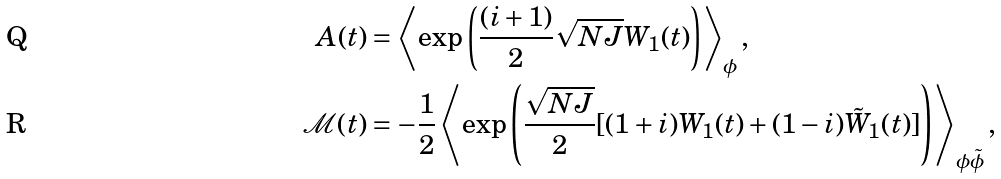Convert formula to latex. <formula><loc_0><loc_0><loc_500><loc_500>A ( t ) & = \left \langle \exp \left ( \frac { ( i + 1 ) } { 2 } \sqrt { N J } W _ { 1 } ( t ) \right ) \right \rangle _ { \phi } , \\ \mathcal { M } ( t ) & = - \frac { 1 } { 2 } \left \langle \exp \left ( \frac { \sqrt { N J } } { 2 } [ ( 1 + i ) W _ { 1 } ( t ) + ( 1 - i ) \tilde { W } _ { 1 } ( t ) ] \right ) \right \rangle _ { \phi \tilde { \phi } } ,</formula> 